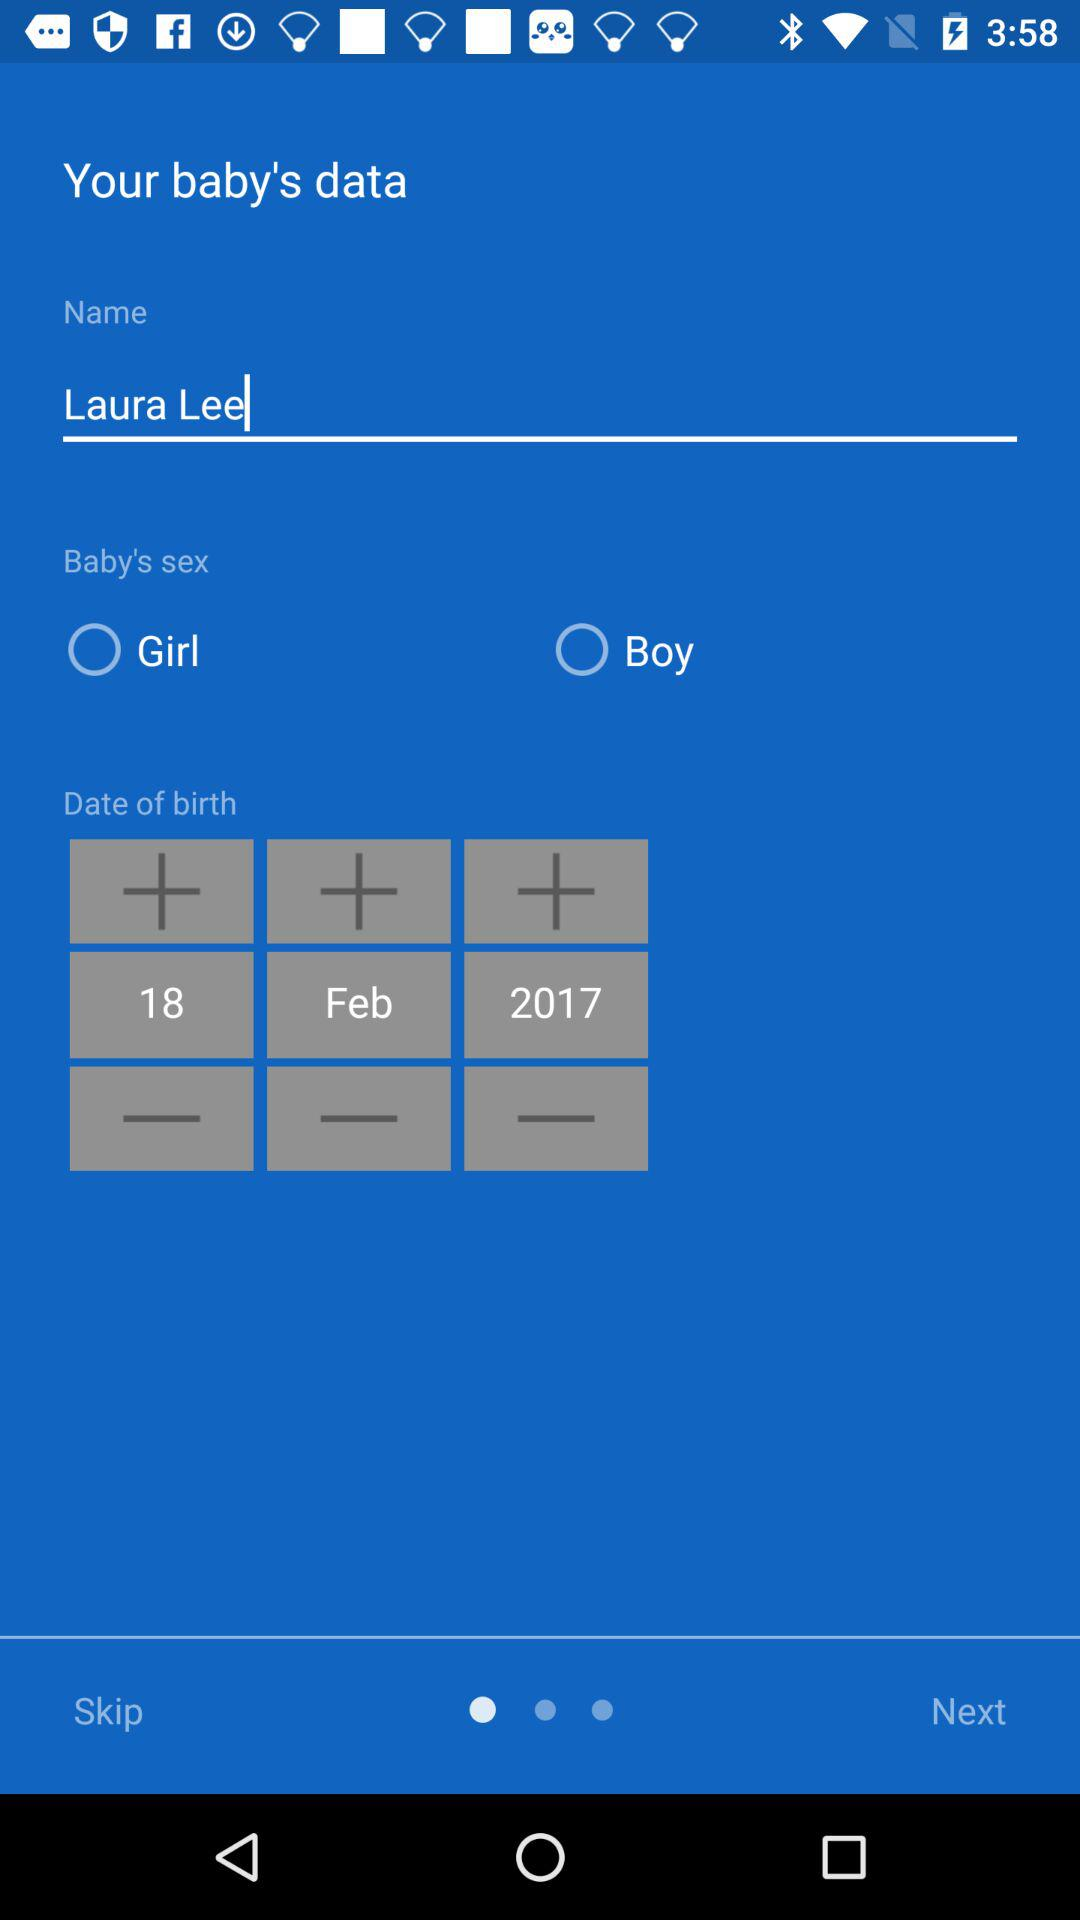Is "Girl" selected or not? It is not selected. 